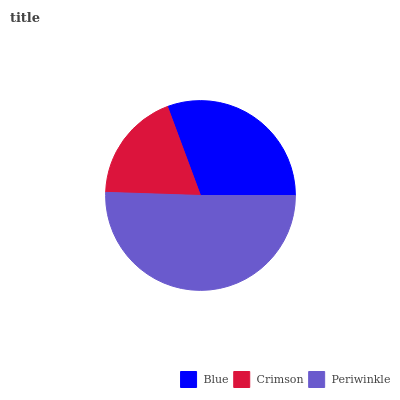Is Crimson the minimum?
Answer yes or no. Yes. Is Periwinkle the maximum?
Answer yes or no. Yes. Is Periwinkle the minimum?
Answer yes or no. No. Is Crimson the maximum?
Answer yes or no. No. Is Periwinkle greater than Crimson?
Answer yes or no. Yes. Is Crimson less than Periwinkle?
Answer yes or no. Yes. Is Crimson greater than Periwinkle?
Answer yes or no. No. Is Periwinkle less than Crimson?
Answer yes or no. No. Is Blue the high median?
Answer yes or no. Yes. Is Blue the low median?
Answer yes or no. Yes. Is Crimson the high median?
Answer yes or no. No. Is Crimson the low median?
Answer yes or no. No. 